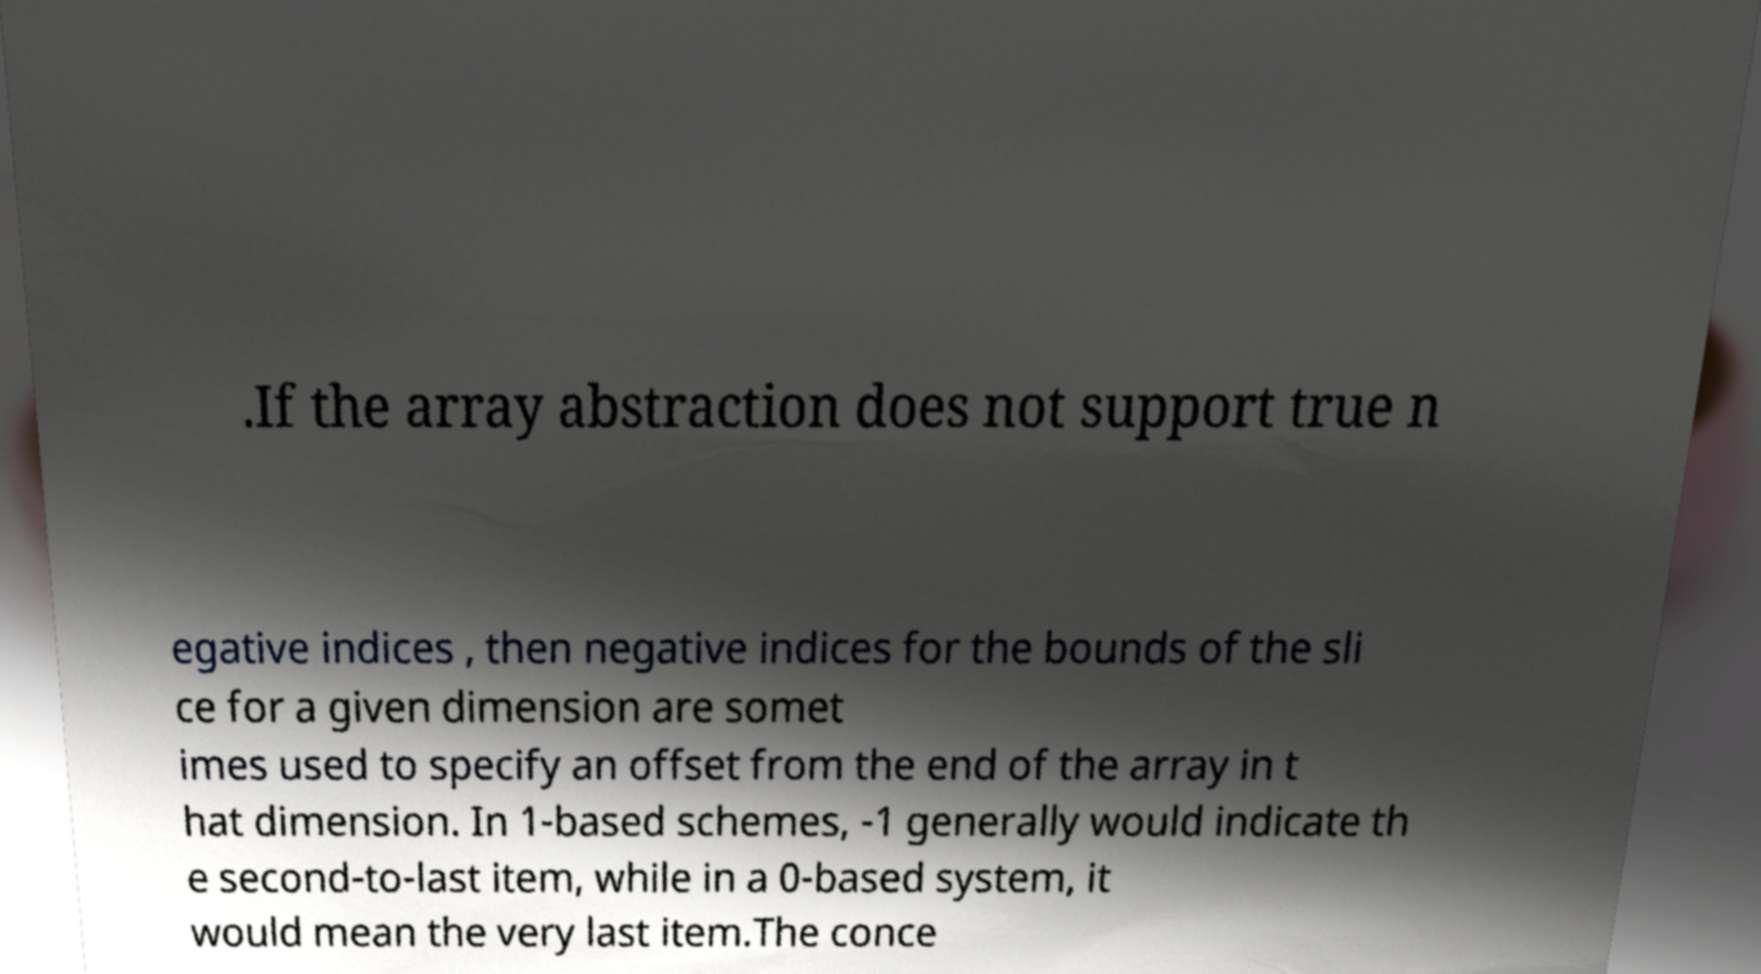Please read and relay the text visible in this image. What does it say? .If the array abstraction does not support true n egative indices , then negative indices for the bounds of the sli ce for a given dimension are somet imes used to specify an offset from the end of the array in t hat dimension. In 1-based schemes, -1 generally would indicate th e second-to-last item, while in a 0-based system, it would mean the very last item.The conce 